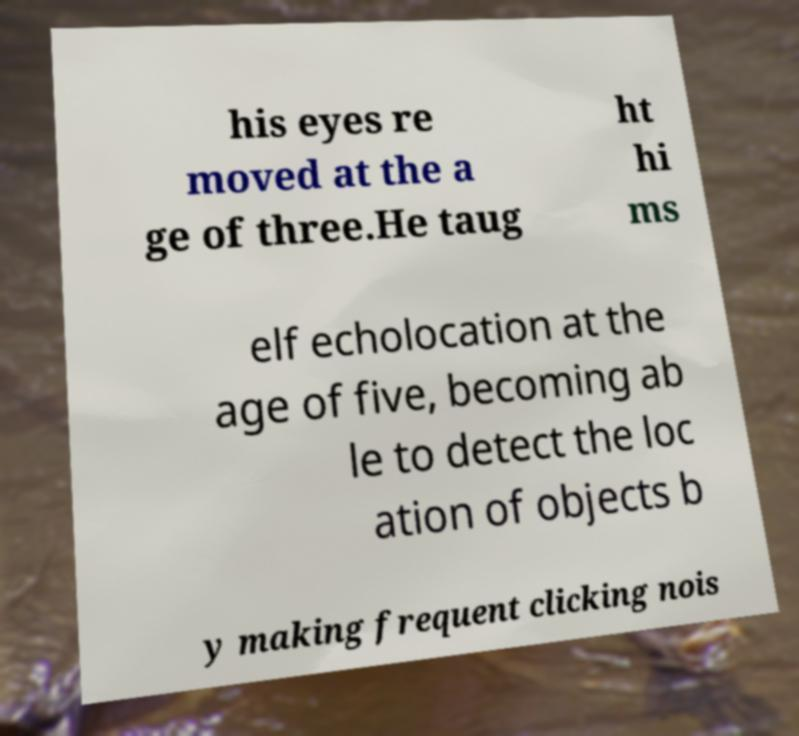Can you accurately transcribe the text from the provided image for me? his eyes re moved at the a ge of three.He taug ht hi ms elf echolocation at the age of five, becoming ab le to detect the loc ation of objects b y making frequent clicking nois 